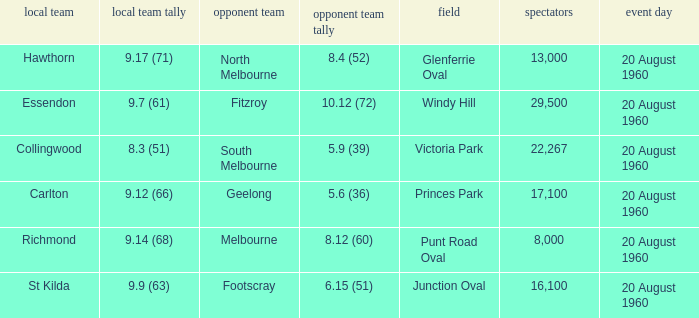Parse the full table. {'header': ['local team', 'local team tally', 'opponent team', 'opponent team tally', 'field', 'spectators', 'event day'], 'rows': [['Hawthorn', '9.17 (71)', 'North Melbourne', '8.4 (52)', 'Glenferrie Oval', '13,000', '20 August 1960'], ['Essendon', '9.7 (61)', 'Fitzroy', '10.12 (72)', 'Windy Hill', '29,500', '20 August 1960'], ['Collingwood', '8.3 (51)', 'South Melbourne', '5.9 (39)', 'Victoria Park', '22,267', '20 August 1960'], ['Carlton', '9.12 (66)', 'Geelong', '5.6 (36)', 'Princes Park', '17,100', '20 August 1960'], ['Richmond', '9.14 (68)', 'Melbourne', '8.12 (60)', 'Punt Road Oval', '8,000', '20 August 1960'], ['St Kilda', '9.9 (63)', 'Footscray', '6.15 (51)', 'Junction Oval', '16,100', '20 August 1960']]} What is the crowd size of the game when Fitzroy is the away team? 1.0. 